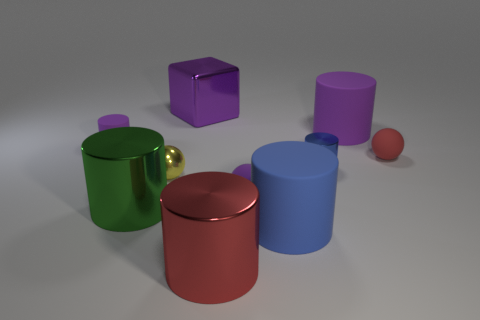What could be the function of the green object with a handle? The green object with a handle looks like a mug without any openings. Its function is not practical in its current form, but it may represent an artistic or conceptual rendition of a mug. 